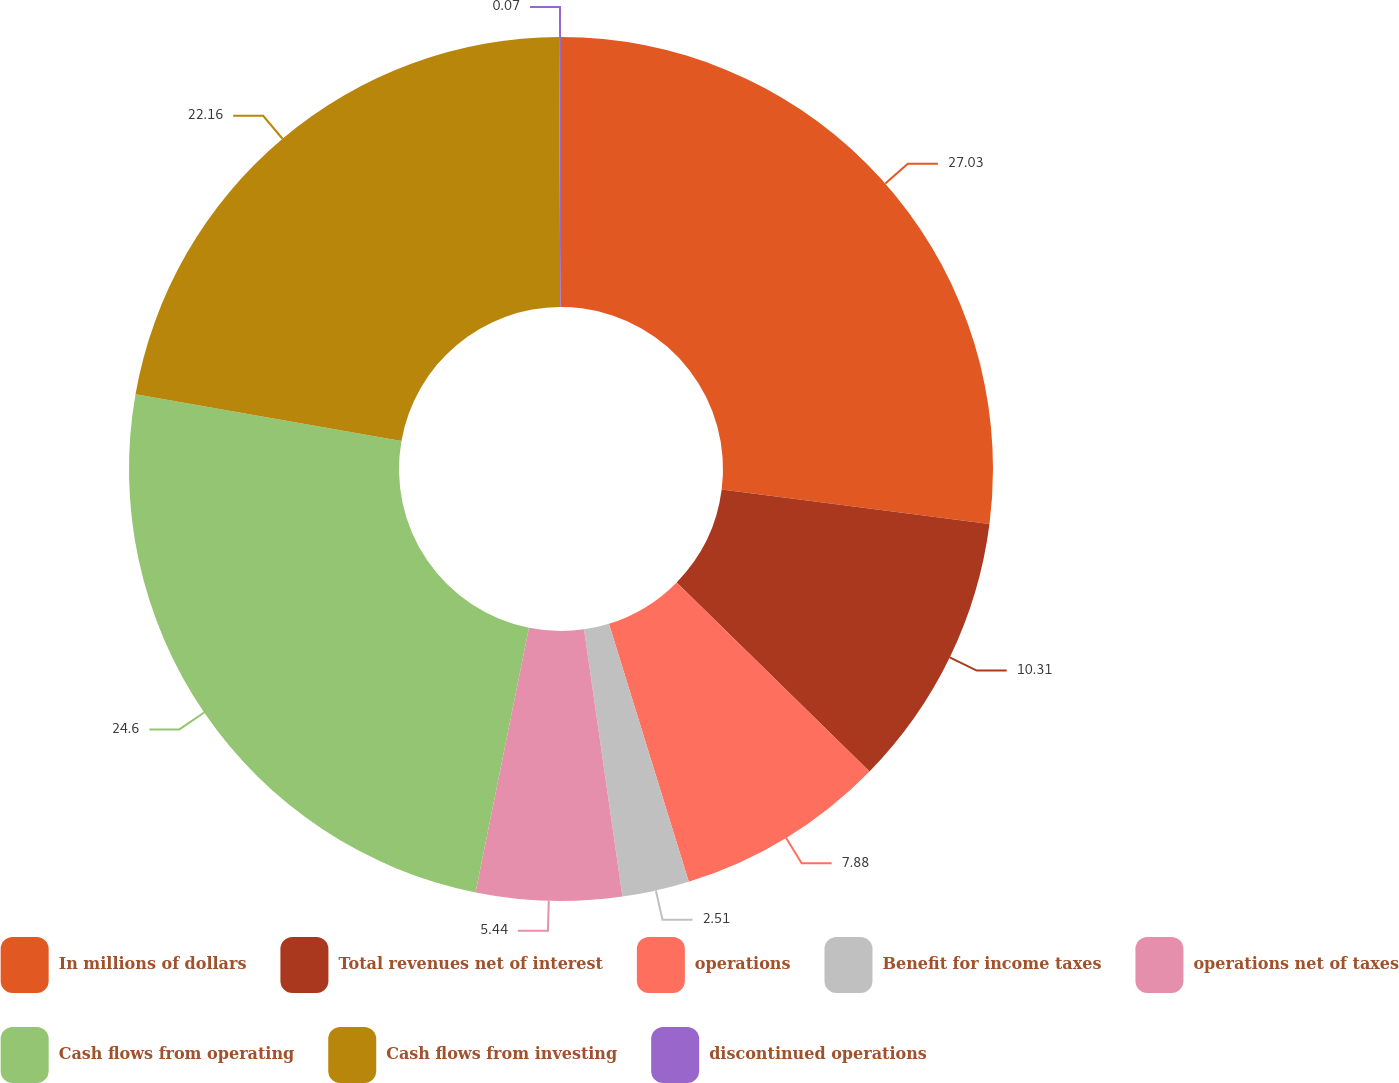Convert chart to OTSL. <chart><loc_0><loc_0><loc_500><loc_500><pie_chart><fcel>In millions of dollars<fcel>Total revenues net of interest<fcel>operations<fcel>Benefit for income taxes<fcel>operations net of taxes<fcel>Cash flows from operating<fcel>Cash flows from investing<fcel>discontinued operations<nl><fcel>27.03%<fcel>10.31%<fcel>7.88%<fcel>2.51%<fcel>5.44%<fcel>24.6%<fcel>22.16%<fcel>0.07%<nl></chart> 